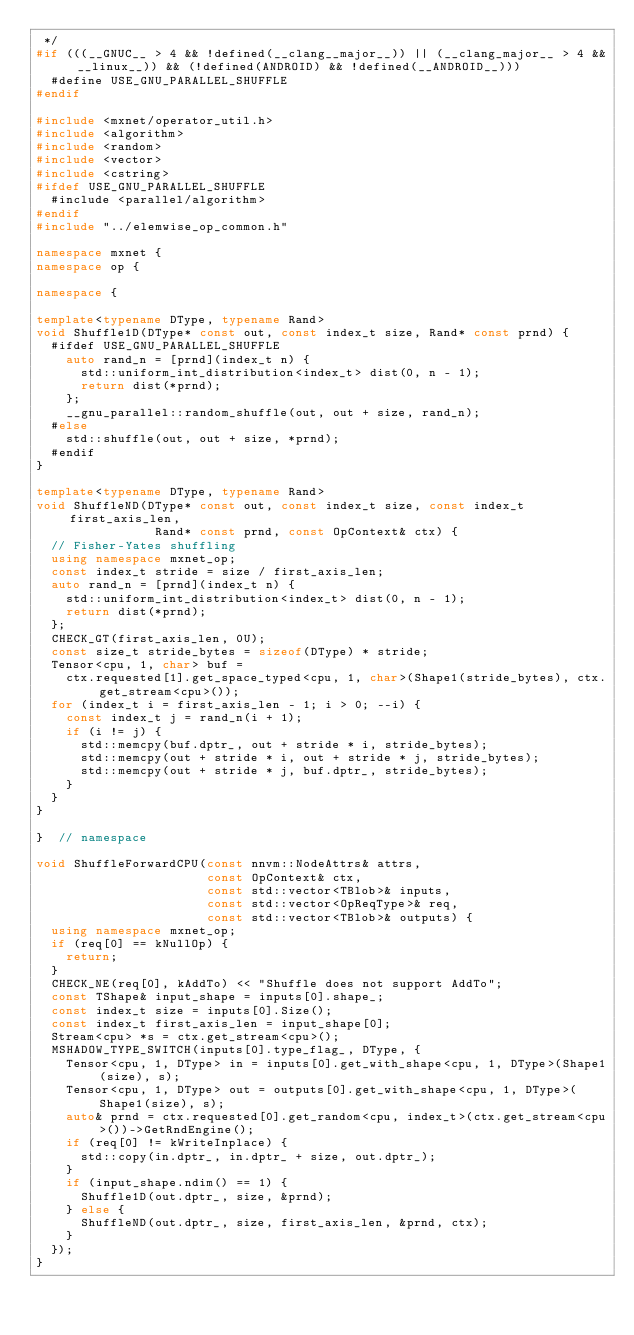<code> <loc_0><loc_0><loc_500><loc_500><_C++_> */
#if (((__GNUC__ > 4 && !defined(__clang__major__)) || (__clang_major__ > 4 && __linux__)) && (!defined(ANDROID) && !defined(__ANDROID__)))
  #define USE_GNU_PARALLEL_SHUFFLE
#endif

#include <mxnet/operator_util.h>
#include <algorithm>
#include <random>
#include <vector>
#include <cstring>
#ifdef USE_GNU_PARALLEL_SHUFFLE
  #include <parallel/algorithm>
#endif
#include "../elemwise_op_common.h"

namespace mxnet {
namespace op {

namespace {

template<typename DType, typename Rand>
void Shuffle1D(DType* const out, const index_t size, Rand* const prnd) {
  #ifdef USE_GNU_PARALLEL_SHUFFLE
    auto rand_n = [prnd](index_t n) {
      std::uniform_int_distribution<index_t> dist(0, n - 1);
      return dist(*prnd);
    };
    __gnu_parallel::random_shuffle(out, out + size, rand_n);
  #else
    std::shuffle(out, out + size, *prnd);
  #endif
}

template<typename DType, typename Rand>
void ShuffleND(DType* const out, const index_t size, const index_t first_axis_len,
                Rand* const prnd, const OpContext& ctx) {
  // Fisher-Yates shuffling
  using namespace mxnet_op;
  const index_t stride = size / first_axis_len;
  auto rand_n = [prnd](index_t n) {
    std::uniform_int_distribution<index_t> dist(0, n - 1);
    return dist(*prnd);
  };
  CHECK_GT(first_axis_len, 0U);
  const size_t stride_bytes = sizeof(DType) * stride;
  Tensor<cpu, 1, char> buf =
    ctx.requested[1].get_space_typed<cpu, 1, char>(Shape1(stride_bytes), ctx.get_stream<cpu>());
  for (index_t i = first_axis_len - 1; i > 0; --i) {
    const index_t j = rand_n(i + 1);
    if (i != j) {
      std::memcpy(buf.dptr_, out + stride * i, stride_bytes);
      std::memcpy(out + stride * i, out + stride * j, stride_bytes);
      std::memcpy(out + stride * j, buf.dptr_, stride_bytes);
    }
  }
}

}  // namespace

void ShuffleForwardCPU(const nnvm::NodeAttrs& attrs,
                       const OpContext& ctx,
                       const std::vector<TBlob>& inputs,
                       const std::vector<OpReqType>& req,
                       const std::vector<TBlob>& outputs) {
  using namespace mxnet_op;
  if (req[0] == kNullOp) {
    return;
  }
  CHECK_NE(req[0], kAddTo) << "Shuffle does not support AddTo";
  const TShape& input_shape = inputs[0].shape_;
  const index_t size = inputs[0].Size();
  const index_t first_axis_len = input_shape[0];
  Stream<cpu> *s = ctx.get_stream<cpu>();
  MSHADOW_TYPE_SWITCH(inputs[0].type_flag_, DType, {
    Tensor<cpu, 1, DType> in = inputs[0].get_with_shape<cpu, 1, DType>(Shape1(size), s);
    Tensor<cpu, 1, DType> out = outputs[0].get_with_shape<cpu, 1, DType>(Shape1(size), s);
    auto& prnd = ctx.requested[0].get_random<cpu, index_t>(ctx.get_stream<cpu>())->GetRndEngine();
    if (req[0] != kWriteInplace) {
      std::copy(in.dptr_, in.dptr_ + size, out.dptr_);
    }
    if (input_shape.ndim() == 1) {
      Shuffle1D(out.dptr_, size, &prnd);
    } else {
      ShuffleND(out.dptr_, size, first_axis_len, &prnd, ctx);
    }
  });
}

</code> 